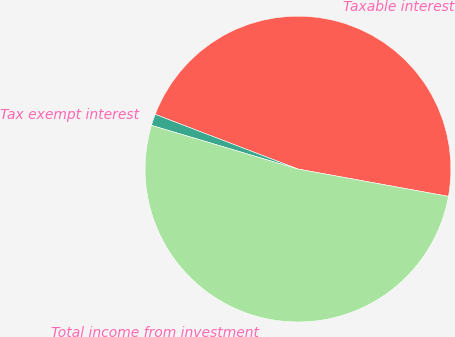<chart> <loc_0><loc_0><loc_500><loc_500><pie_chart><fcel>Taxable interest<fcel>Tax exempt interest<fcel>Total income from investment<nl><fcel>47.04%<fcel>1.21%<fcel>51.75%<nl></chart> 